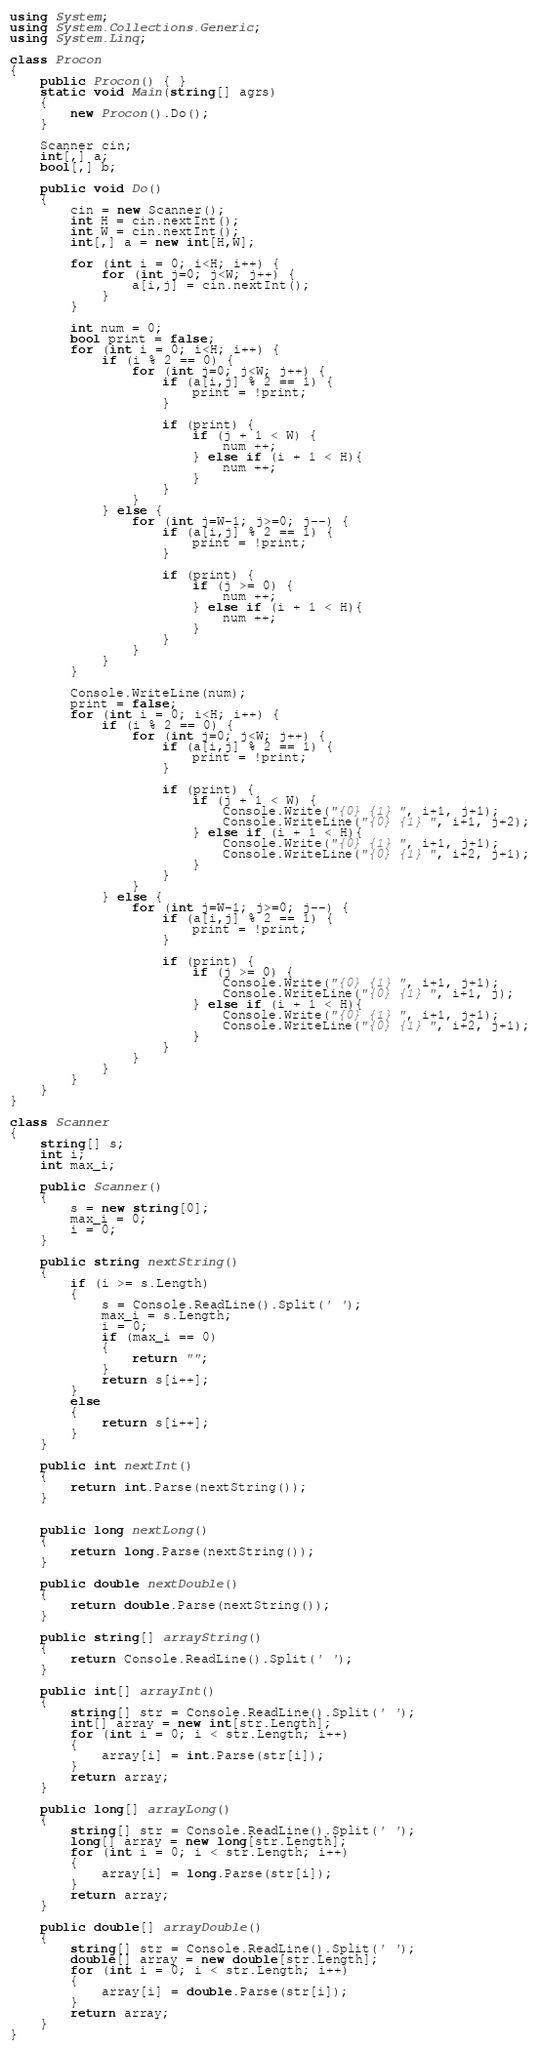<code> <loc_0><loc_0><loc_500><loc_500><_C#_>using System;
using System.Collections.Generic;
using System.Linq;

class Procon
{
    public Procon() { }
    static void Main(string[] agrs)
    {
        new Procon().Do();
    }

    Scanner cin;
    int[,] a;
    bool[,] b;

    public void Do()
    {
        cin = new Scanner();
        int H = cin.nextInt();
        int W = cin.nextInt();
        int[,] a = new int[H,W];

        for (int i = 0; i<H; i++) {
            for (int j=0; j<W; j++) {
                a[i,j] = cin.nextInt();
            }
        }

        int num = 0;
        bool print = false;
        for (int i = 0; i<H; i++) {
            if (i % 2 == 0) {
                for (int j=0; j<W; j++) {
                    if (a[i,j] % 2 == 1) {
                        print = !print;
                    }

                    if (print) {
                        if (j + 1 < W) {
                            num ++;
                        } else if (i + 1 < H){
                            num ++;
                        }
                    }
                }
            } else {
                for (int j=W-1; j>=0; j--) {
                    if (a[i,j] % 2 == 1) {
                        print = !print;
                    }

                    if (print) {
                        if (j >= 0) {
                            num ++;
                        } else if (i + 1 < H){
                            num ++;
                        }
                    }
                }
            }
        }

        Console.WriteLine(num);
        print = false;
        for (int i = 0; i<H; i++) {
            if (i % 2 == 0) {
                for (int j=0; j<W; j++) {
                    if (a[i,j] % 2 == 1) {
                        print = !print;
                    }

                    if (print) {
                        if (j + 1 < W) {
                            Console.Write("{0} {1} ", i+1, j+1);
                            Console.WriteLine("{0} {1} ", i+1, j+2);
                        } else if (i + 1 < H){
                            Console.Write("{0} {1} ", i+1, j+1);
                            Console.WriteLine("{0} {1} ", i+2, j+1);
                        }
                    }
                }
            } else {
                for (int j=W-1; j>=0; j--) {
                    if (a[i,j] % 2 == 1) {
                        print = !print;
                    }

                    if (print) {
                        if (j >= 0) {
                            Console.Write("{0} {1} ", i+1, j+1);
                            Console.WriteLine("{0} {1} ", i+1, j);
                        } else if (i + 1 < H){
                            Console.Write("{0} {1} ", i+1, j+1);
                            Console.WriteLine("{0} {1} ", i+2, j+1);
                        }
                    }
                }
            }
        }
    }
}

class Scanner
{
    string[] s;
    int i;
    int max_i;

    public Scanner()
    {
        s = new string[0];
        max_i = 0;
        i = 0;
    }

    public string nextString()
    {
        if (i >= s.Length)
        {
            s = Console.ReadLine().Split(' ');
            max_i = s.Length;
            i = 0;
            if (max_i == 0)
            {
                return "";
            }
            return s[i++];
        }
        else
        {
            return s[i++];
        }
    }

    public int nextInt()
    {
        return int.Parse(nextString());
    }


    public long nextLong()
    {
        return long.Parse(nextString());
    }

    public double nextDouble()
    {
        return double.Parse(nextString());
    }

    public string[] arrayString()
    {
        return Console.ReadLine().Split(' ');
    }

    public int[] arrayInt()
    {
        string[] str = Console.ReadLine().Split(' ');
        int[] array = new int[str.Length];
        for (int i = 0; i < str.Length; i++)
        {
            array[i] = int.Parse(str[i]);
        }
        return array;
    }

    public long[] arrayLong()
    {
        string[] str = Console.ReadLine().Split(' ');
        long[] array = new long[str.Length];
        for (int i = 0; i < str.Length; i++)
        {
            array[i] = long.Parse(str[i]);
        }
        return array;
    }

    public double[] arrayDouble()
    {
        string[] str = Console.ReadLine().Split(' ');
        double[] array = new double[str.Length];
        for (int i = 0; i < str.Length; i++)
        {
            array[i] = double.Parse(str[i]);
        }
        return array;
    }
}
</code> 